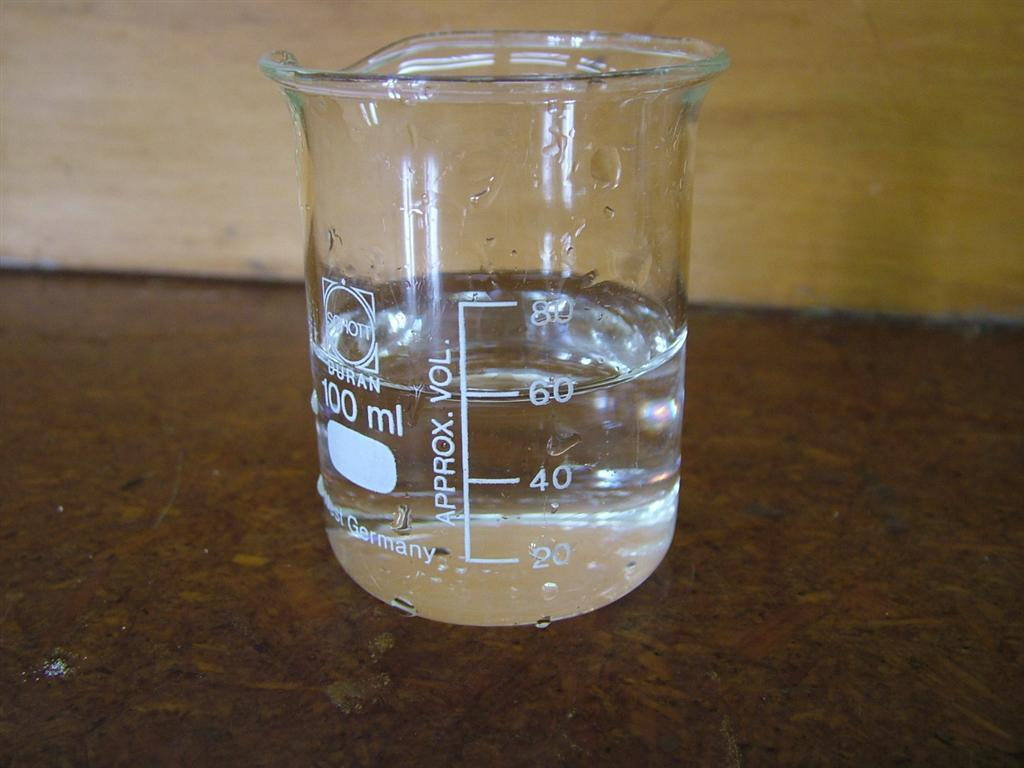<image>
Describe the image concisely. A beaker is filled with clear liquid up to the 60 line. 